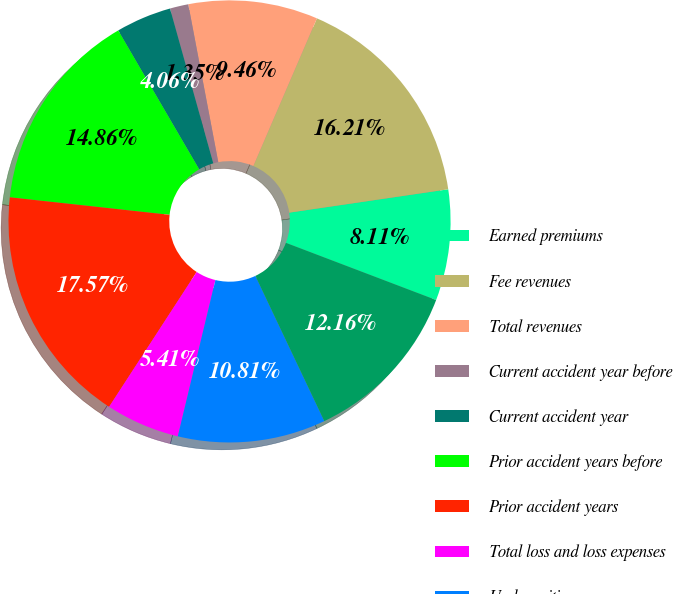Convert chart. <chart><loc_0><loc_0><loc_500><loc_500><pie_chart><fcel>Earned premiums<fcel>Fee revenues<fcel>Total revenues<fcel>Current accident year before<fcel>Current accident year<fcel>Prior accident years before<fcel>Prior accident years<fcel>Total loss and loss expenses<fcel>Underwriting expenses<fcel>Total loss and loss expense<nl><fcel>8.11%<fcel>16.21%<fcel>9.46%<fcel>1.35%<fcel>4.06%<fcel>14.86%<fcel>17.57%<fcel>5.41%<fcel>10.81%<fcel>12.16%<nl></chart> 